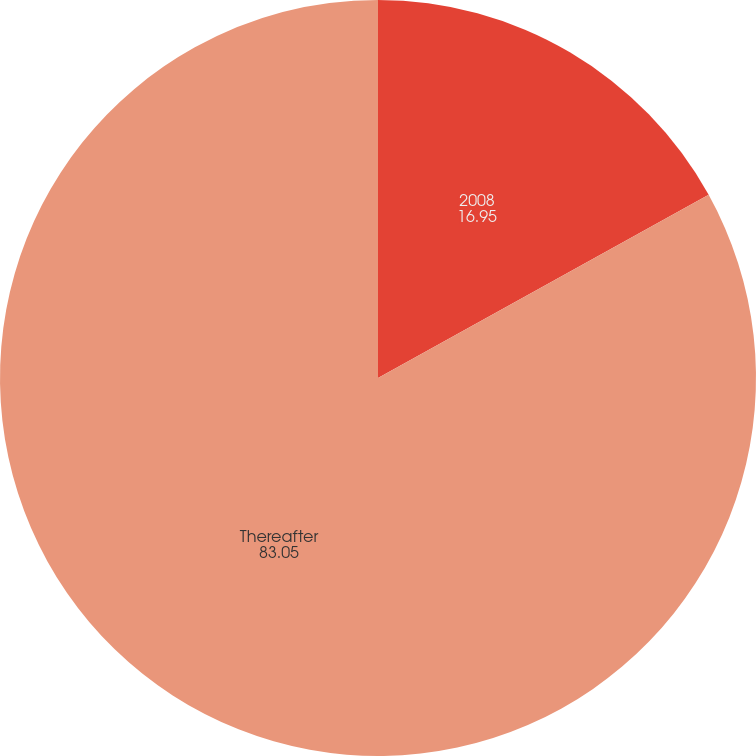<chart> <loc_0><loc_0><loc_500><loc_500><pie_chart><fcel>2008<fcel>Thereafter<nl><fcel>16.95%<fcel>83.05%<nl></chart> 